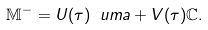Convert formula to latex. <formula><loc_0><loc_0><loc_500><loc_500>\mathbb { M } ^ { - } = U ( \tau ) \ u m a + V ( \tau ) \mathbb { C } .</formula> 